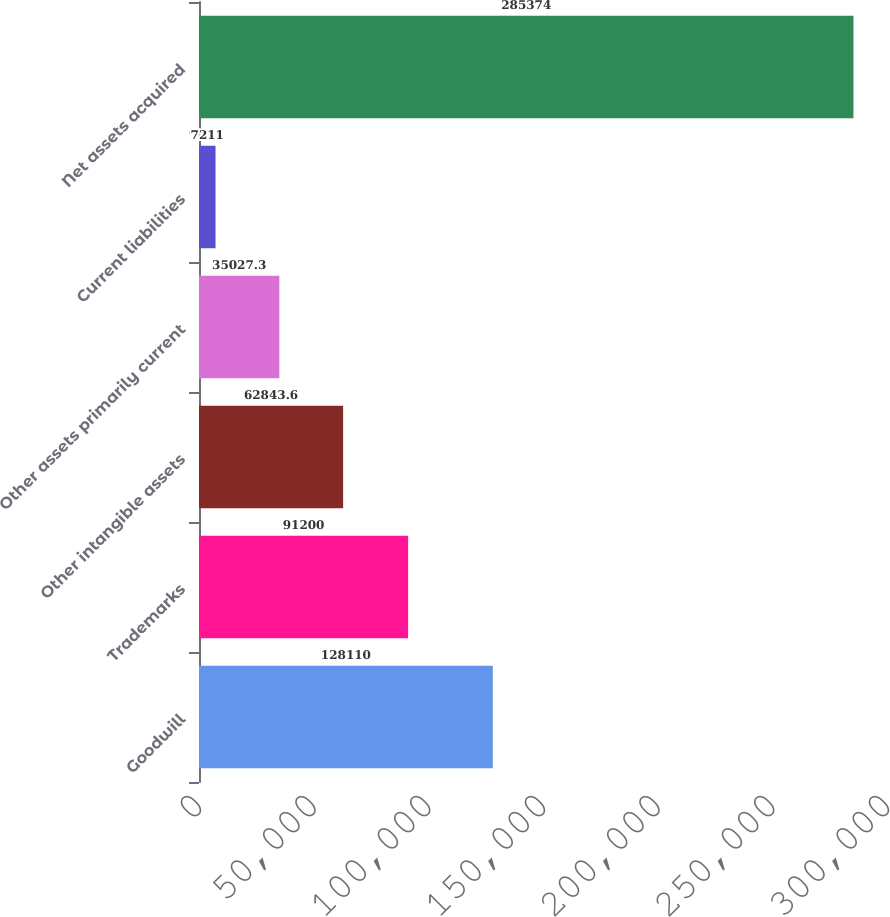Convert chart to OTSL. <chart><loc_0><loc_0><loc_500><loc_500><bar_chart><fcel>Goodwill<fcel>Trademarks<fcel>Other intangible assets<fcel>Other assets primarily current<fcel>Current liabilities<fcel>Net assets acquired<nl><fcel>128110<fcel>91200<fcel>62843.6<fcel>35027.3<fcel>7211<fcel>285374<nl></chart> 